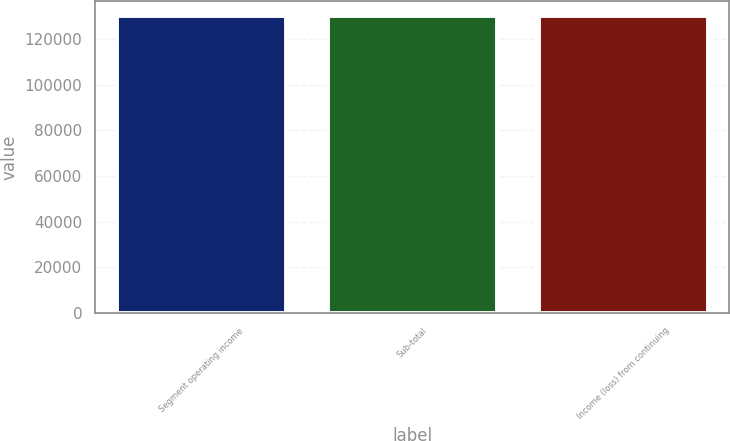Convert chart to OTSL. <chart><loc_0><loc_0><loc_500><loc_500><bar_chart><fcel>Segment operating income<fcel>Sub-total<fcel>Income (loss) from continuing<nl><fcel>130280<fcel>130280<fcel>130280<nl></chart> 